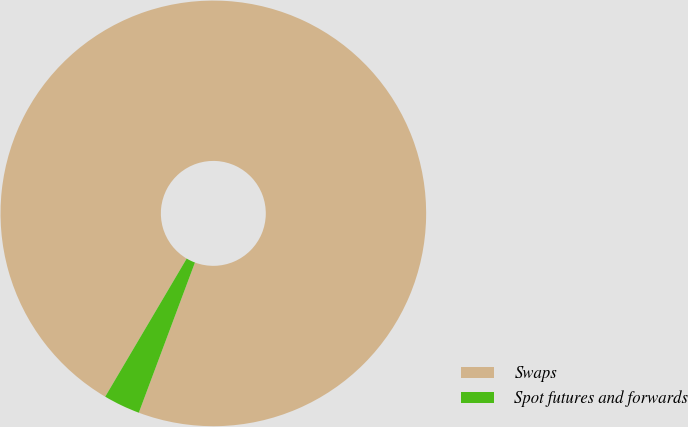Convert chart to OTSL. <chart><loc_0><loc_0><loc_500><loc_500><pie_chart><fcel>Swaps<fcel>Spot futures and forwards<nl><fcel>97.21%<fcel>2.79%<nl></chart> 